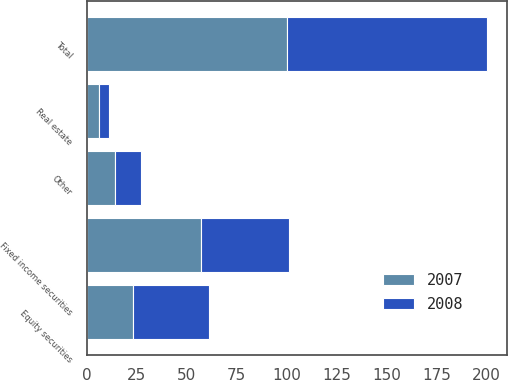<chart> <loc_0><loc_0><loc_500><loc_500><stacked_bar_chart><ecel><fcel>Equity securities<fcel>Fixed income securities<fcel>Real estate<fcel>Other<fcel>Total<nl><fcel>2007<fcel>23<fcel>57<fcel>6<fcel>14<fcel>100<nl><fcel>2008<fcel>38<fcel>44<fcel>5<fcel>13<fcel>100<nl></chart> 